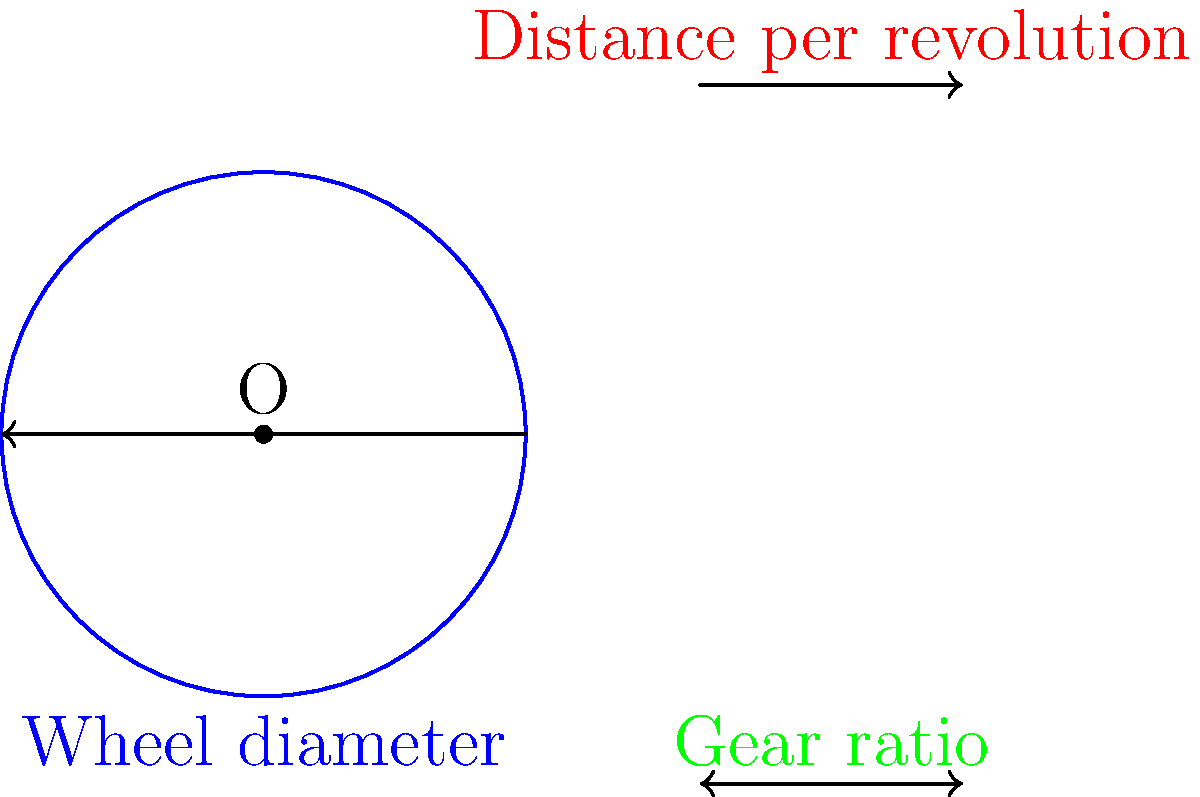A professional cyclist is testing a new bike setup. The bike has wheels with a diameter of 27 inches and is using a gear ratio of 4:1. If the cyclist completes one full pedal revolution, how far will the bike travel in feet? Let's break this down step-by-step:

1) First, we need to calculate the circumference of the wheel:
   Circumference = $\pi \times diameter$
   Circumference = $\pi \times 27$ inches = $84.82$ inches

2) Now, we know that one complete rotation of the wheel will move the bike this distance.

3) However, we're dealing with a gear ratio of 4:1. This means that for every one revolution of the pedals, the wheel will rotate 4 times.

4) So, the distance traveled for one pedal revolution is:
   Distance = $4 \times 84.82$ inches = $339.28$ inches

5) The question asks for the answer in feet, so we need to convert:
   $339.28$ inches = $339.28 \div 12$ feet = $28.27$ feet

Therefore, for one full pedal revolution, the bike will travel approximately 28.27 feet.
Answer: 28.27 feet 